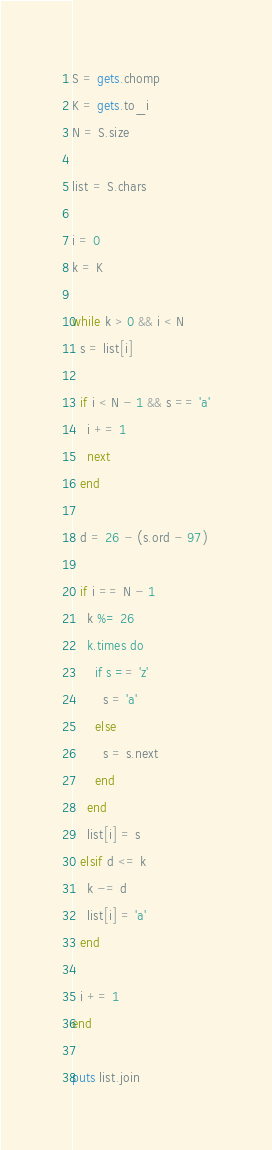<code> <loc_0><loc_0><loc_500><loc_500><_Ruby_>S = gets.chomp
K = gets.to_i
N = S.size

list = S.chars

i = 0
k = K

while k > 0 && i < N
  s = list[i]

  if i < N - 1 && s == 'a'
    i += 1
    next
  end

  d = 26 - (s.ord - 97)

  if i == N - 1
    k %= 26
    k.times do
      if s == 'z'
        s = 'a'
      else
        s = s.next
      end
    end
    list[i] = s
  elsif d <= k
    k -= d
    list[i] = 'a'
  end

  i += 1
end

puts list.join
</code> 